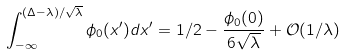Convert formula to latex. <formula><loc_0><loc_0><loc_500><loc_500>\int _ { - \infty } ^ { ( \Delta - \lambda ) / \sqrt { \lambda } } \phi _ { 0 } ( x ^ { \prime } ) d x ^ { \prime } = 1 / 2 - \frac { \phi _ { 0 } ( 0 ) } { 6 \sqrt { \lambda } } + { \mathcal { O } } ( 1 / \lambda )</formula> 